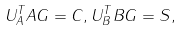<formula> <loc_0><loc_0><loc_500><loc_500>U _ { A } ^ { T } A G = C , U _ { B } ^ { T } B G = S ,</formula> 